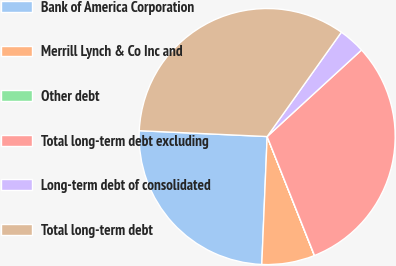Convert chart. <chart><loc_0><loc_0><loc_500><loc_500><pie_chart><fcel>Bank of America Corporation<fcel>Merrill Lynch & Co Inc and<fcel>Other debt<fcel>Total long-term debt excluding<fcel>Long-term debt of consolidated<fcel>Total long-term debt<nl><fcel>25.06%<fcel>6.68%<fcel>0.02%<fcel>30.78%<fcel>3.35%<fcel>34.11%<nl></chart> 